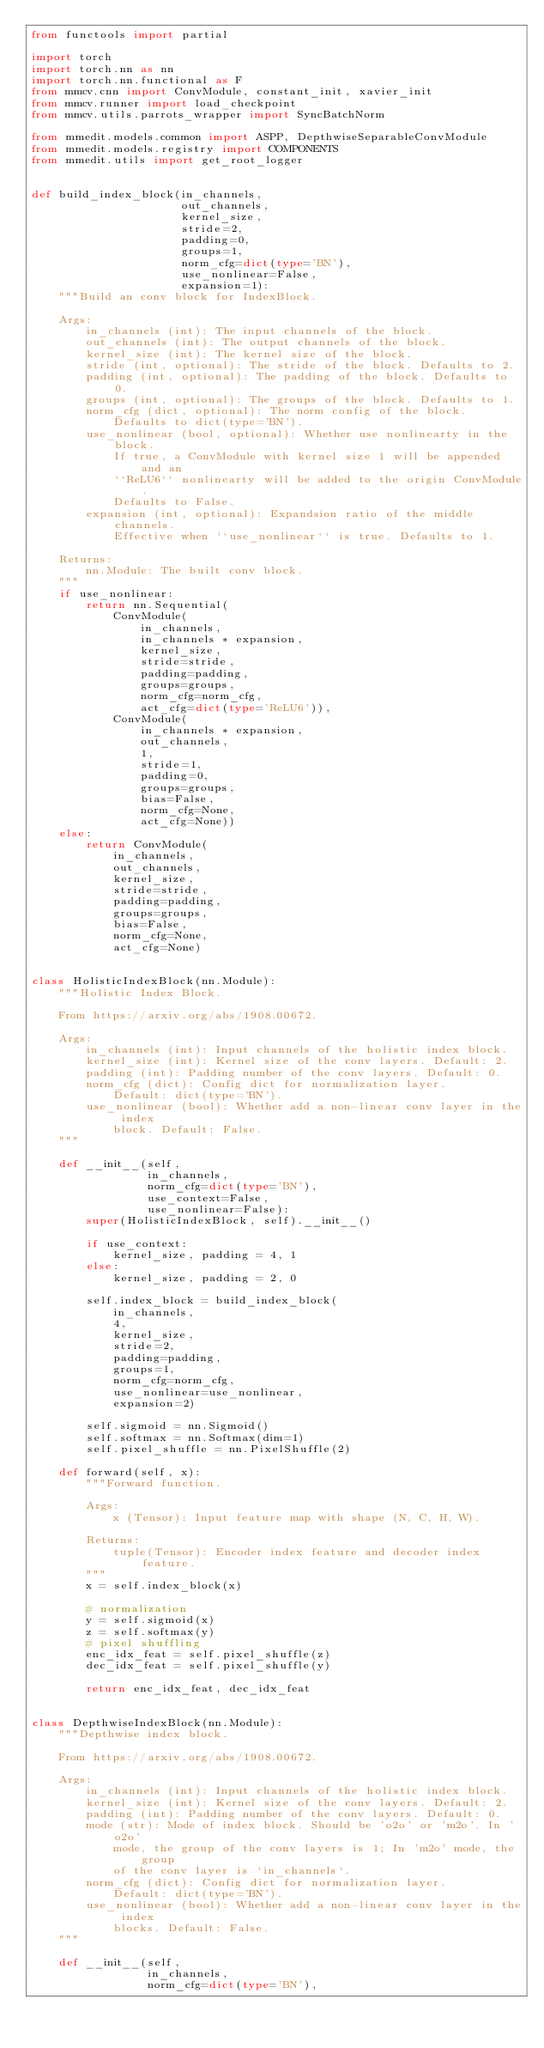Convert code to text. <code><loc_0><loc_0><loc_500><loc_500><_Python_>from functools import partial

import torch
import torch.nn as nn
import torch.nn.functional as F
from mmcv.cnn import ConvModule, constant_init, xavier_init
from mmcv.runner import load_checkpoint
from mmcv.utils.parrots_wrapper import SyncBatchNorm

from mmedit.models.common import ASPP, DepthwiseSeparableConvModule
from mmedit.models.registry import COMPONENTS
from mmedit.utils import get_root_logger


def build_index_block(in_channels,
                      out_channels,
                      kernel_size,
                      stride=2,
                      padding=0,
                      groups=1,
                      norm_cfg=dict(type='BN'),
                      use_nonlinear=False,
                      expansion=1):
    """Build an conv block for IndexBlock.

    Args:
        in_channels (int): The input channels of the block.
        out_channels (int): The output channels of the block.
        kernel_size (int): The kernel size of the block.
        stride (int, optional): The stride of the block. Defaults to 2.
        padding (int, optional): The padding of the block. Defaults to 0.
        groups (int, optional): The groups of the block. Defaults to 1.
        norm_cfg (dict, optional): The norm config of the block.
            Defaults to dict(type='BN').
        use_nonlinear (bool, optional): Whether use nonlinearty in the block.
            If true, a ConvModule with kernel size 1 will be appended and an
            ``ReLU6`` nonlinearty will be added to the origin ConvModule.
            Defaults to False.
        expansion (int, optional): Expandsion ratio of the middle channels.
            Effective when ``use_nonlinear`` is true. Defaults to 1.

    Returns:
        nn.Module: The built conv block.
    """
    if use_nonlinear:
        return nn.Sequential(
            ConvModule(
                in_channels,
                in_channels * expansion,
                kernel_size,
                stride=stride,
                padding=padding,
                groups=groups,
                norm_cfg=norm_cfg,
                act_cfg=dict(type='ReLU6')),
            ConvModule(
                in_channels * expansion,
                out_channels,
                1,
                stride=1,
                padding=0,
                groups=groups,
                bias=False,
                norm_cfg=None,
                act_cfg=None))
    else:
        return ConvModule(
            in_channels,
            out_channels,
            kernel_size,
            stride=stride,
            padding=padding,
            groups=groups,
            bias=False,
            norm_cfg=None,
            act_cfg=None)


class HolisticIndexBlock(nn.Module):
    """Holistic Index Block.

    From https://arxiv.org/abs/1908.00672.

    Args:
        in_channels (int): Input channels of the holistic index block.
        kernel_size (int): Kernel size of the conv layers. Default: 2.
        padding (int): Padding number of the conv layers. Default: 0.
        norm_cfg (dict): Config dict for normalization layer.
            Default: dict(type='BN').
        use_nonlinear (bool): Whether add a non-linear conv layer in the index
            block. Default: False.
    """

    def __init__(self,
                 in_channels,
                 norm_cfg=dict(type='BN'),
                 use_context=False,
                 use_nonlinear=False):
        super(HolisticIndexBlock, self).__init__()

        if use_context:
            kernel_size, padding = 4, 1
        else:
            kernel_size, padding = 2, 0

        self.index_block = build_index_block(
            in_channels,
            4,
            kernel_size,
            stride=2,
            padding=padding,
            groups=1,
            norm_cfg=norm_cfg,
            use_nonlinear=use_nonlinear,
            expansion=2)

        self.sigmoid = nn.Sigmoid()
        self.softmax = nn.Softmax(dim=1)
        self.pixel_shuffle = nn.PixelShuffle(2)

    def forward(self, x):
        """Forward function.

        Args:
            x (Tensor): Input feature map with shape (N, C, H, W).

        Returns:
            tuple(Tensor): Encoder index feature and decoder index feature.
        """
        x = self.index_block(x)

        # normalization
        y = self.sigmoid(x)
        z = self.softmax(y)
        # pixel shuffling
        enc_idx_feat = self.pixel_shuffle(z)
        dec_idx_feat = self.pixel_shuffle(y)

        return enc_idx_feat, dec_idx_feat


class DepthwiseIndexBlock(nn.Module):
    """Depthwise index block.

    From https://arxiv.org/abs/1908.00672.

    Args:
        in_channels (int): Input channels of the holistic index block.
        kernel_size (int): Kernel size of the conv layers. Default: 2.
        padding (int): Padding number of the conv layers. Default: 0.
        mode (str): Mode of index block. Should be 'o2o' or 'm2o'. In 'o2o'
            mode, the group of the conv layers is 1; In 'm2o' mode, the group
            of the conv layer is `in_channels`.
        norm_cfg (dict): Config dict for normalization layer.
            Default: dict(type='BN').
        use_nonlinear (bool): Whether add a non-linear conv layer in the index
            blocks. Default: False.
    """

    def __init__(self,
                 in_channels,
                 norm_cfg=dict(type='BN'),</code> 